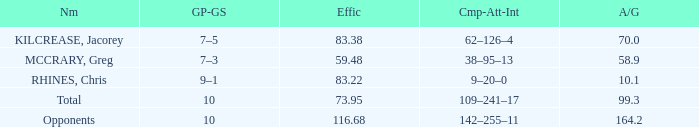What is the lowest effic with a 58.9 avg/g? 59.48. 